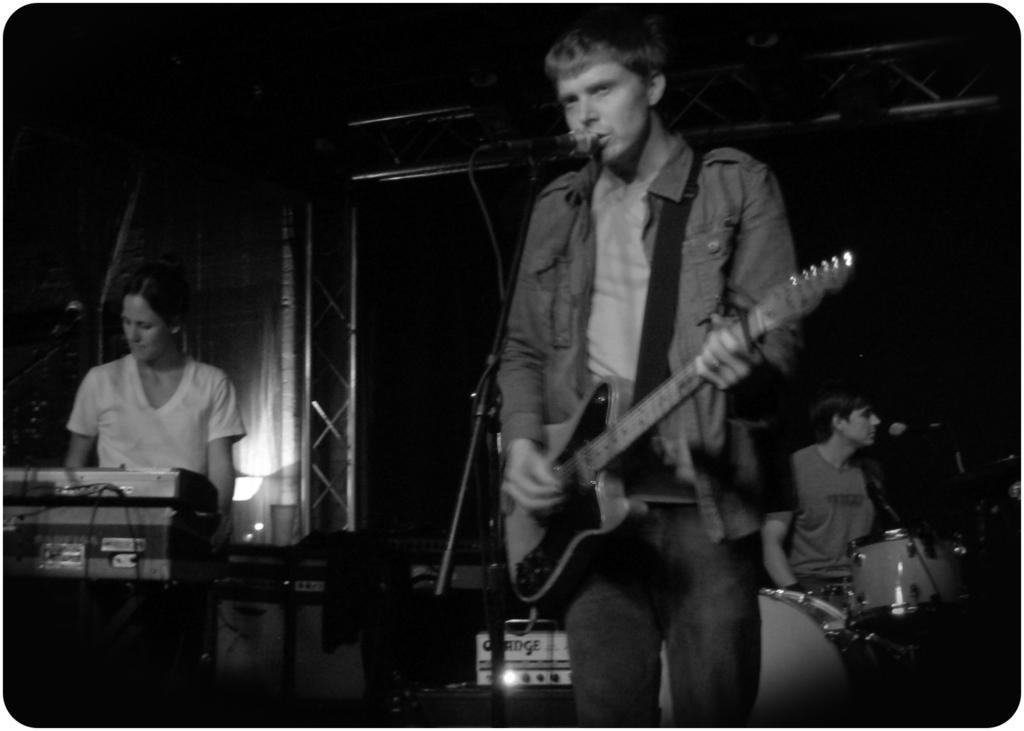Describe this image in one or two sentences. In this image I can see two men and a woman, I can also see they all are holding musical instruments. Here I can see a mic in front of him. 